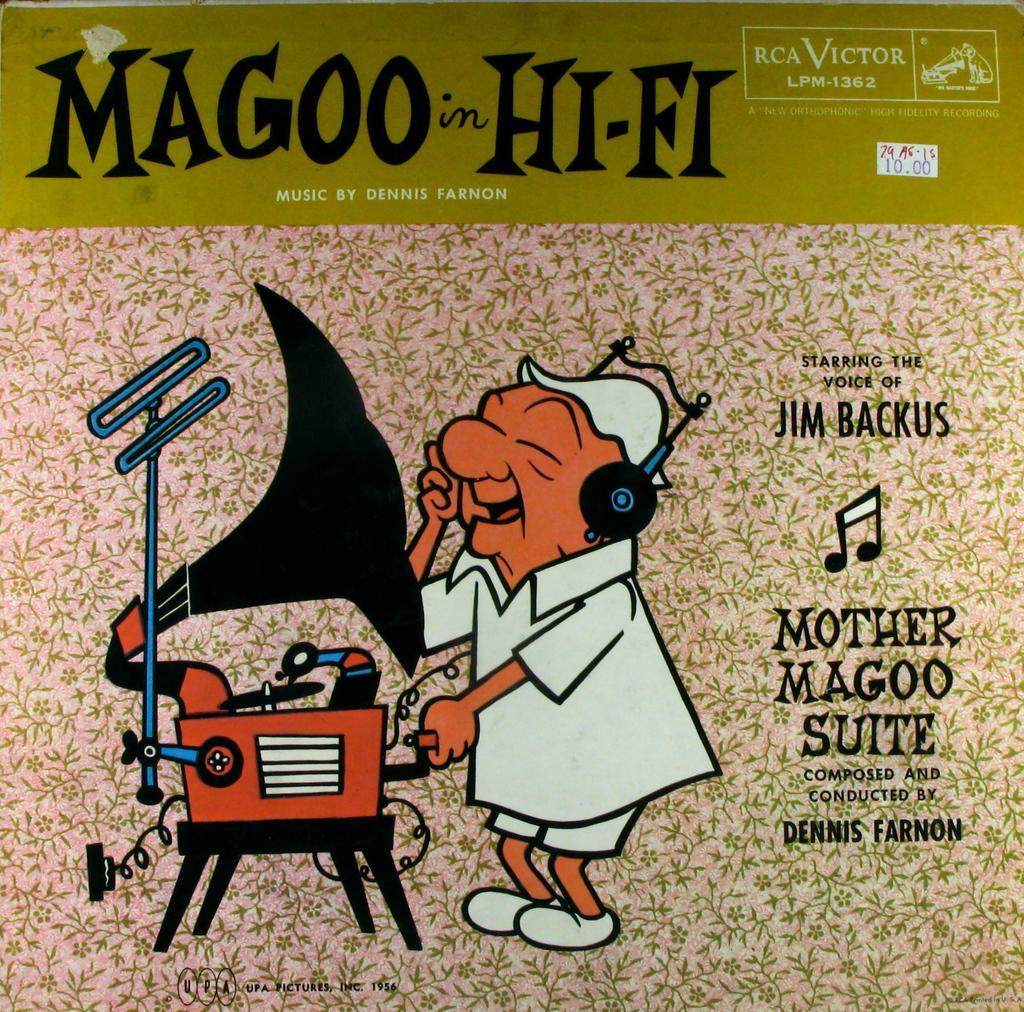Please provide a concise description of this image. This is a poster and in this poster we can see a person wore cap and in front of him we can see a stand and a device. 